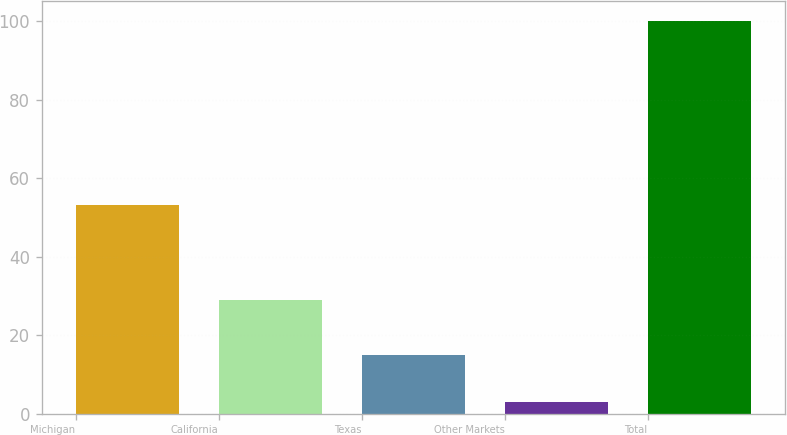Convert chart. <chart><loc_0><loc_0><loc_500><loc_500><bar_chart><fcel>Michigan<fcel>California<fcel>Texas<fcel>Other Markets<fcel>Total<nl><fcel>53<fcel>29<fcel>15<fcel>3<fcel>100<nl></chart> 